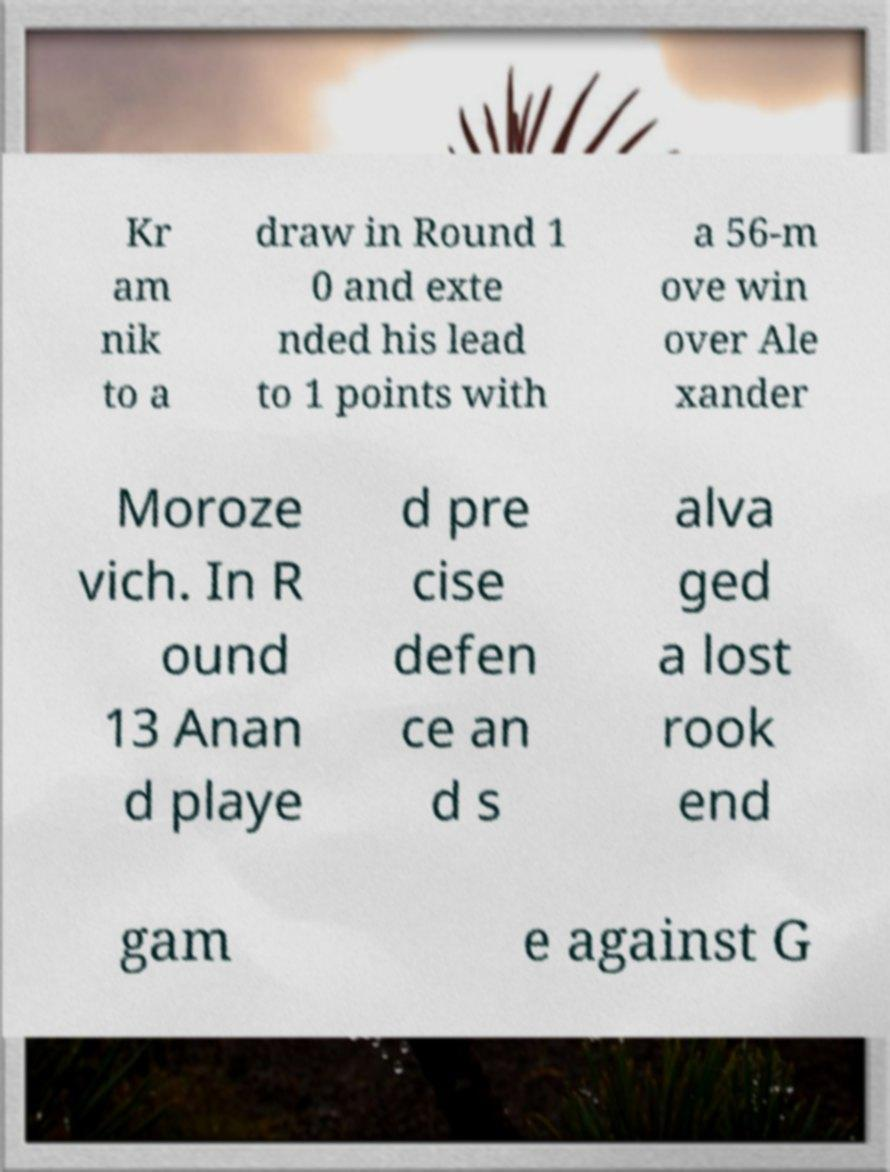There's text embedded in this image that I need extracted. Can you transcribe it verbatim? Kr am nik to a draw in Round 1 0 and exte nded his lead to 1 points with a 56-m ove win over Ale xander Moroze vich. In R ound 13 Anan d playe d pre cise defen ce an d s alva ged a lost rook end gam e against G 